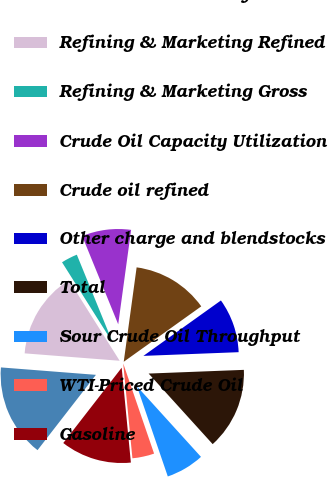Convert chart to OTSL. <chart><loc_0><loc_0><loc_500><loc_500><pie_chart><fcel>MPC Consolidated Refined<fcel>Refining & Marketing Refined<fcel>Refining & Marketing Gross<fcel>Crude Oil Capacity Utilization<fcel>Crude oil refined<fcel>Other charge and blendstocks<fcel>Total<fcel>Sour Crude Oil Throughput<fcel>WTI-Priced Crude Oil<fcel>Gasoline<nl><fcel>15.74%<fcel>14.81%<fcel>2.78%<fcel>8.33%<fcel>12.96%<fcel>9.26%<fcel>13.89%<fcel>6.48%<fcel>3.71%<fcel>12.04%<nl></chart> 